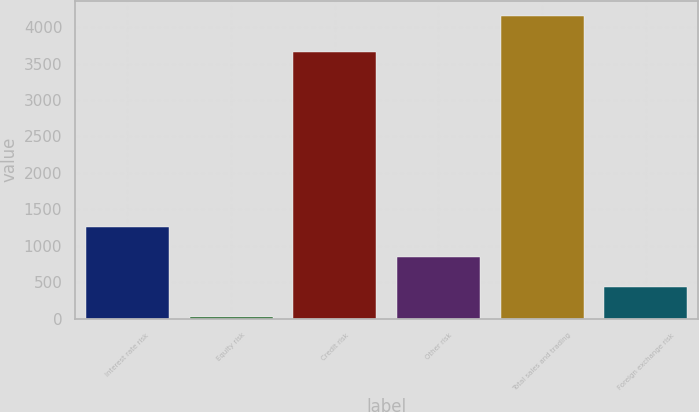<chart> <loc_0><loc_0><loc_500><loc_500><bar_chart><fcel>Interest rate risk<fcel>Equity risk<fcel>Credit risk<fcel>Other risk<fcel>Total sales and trading<fcel>Foreign exchange risk<nl><fcel>1261.2<fcel>21<fcel>3652<fcel>847.8<fcel>4155<fcel>434.4<nl></chart> 